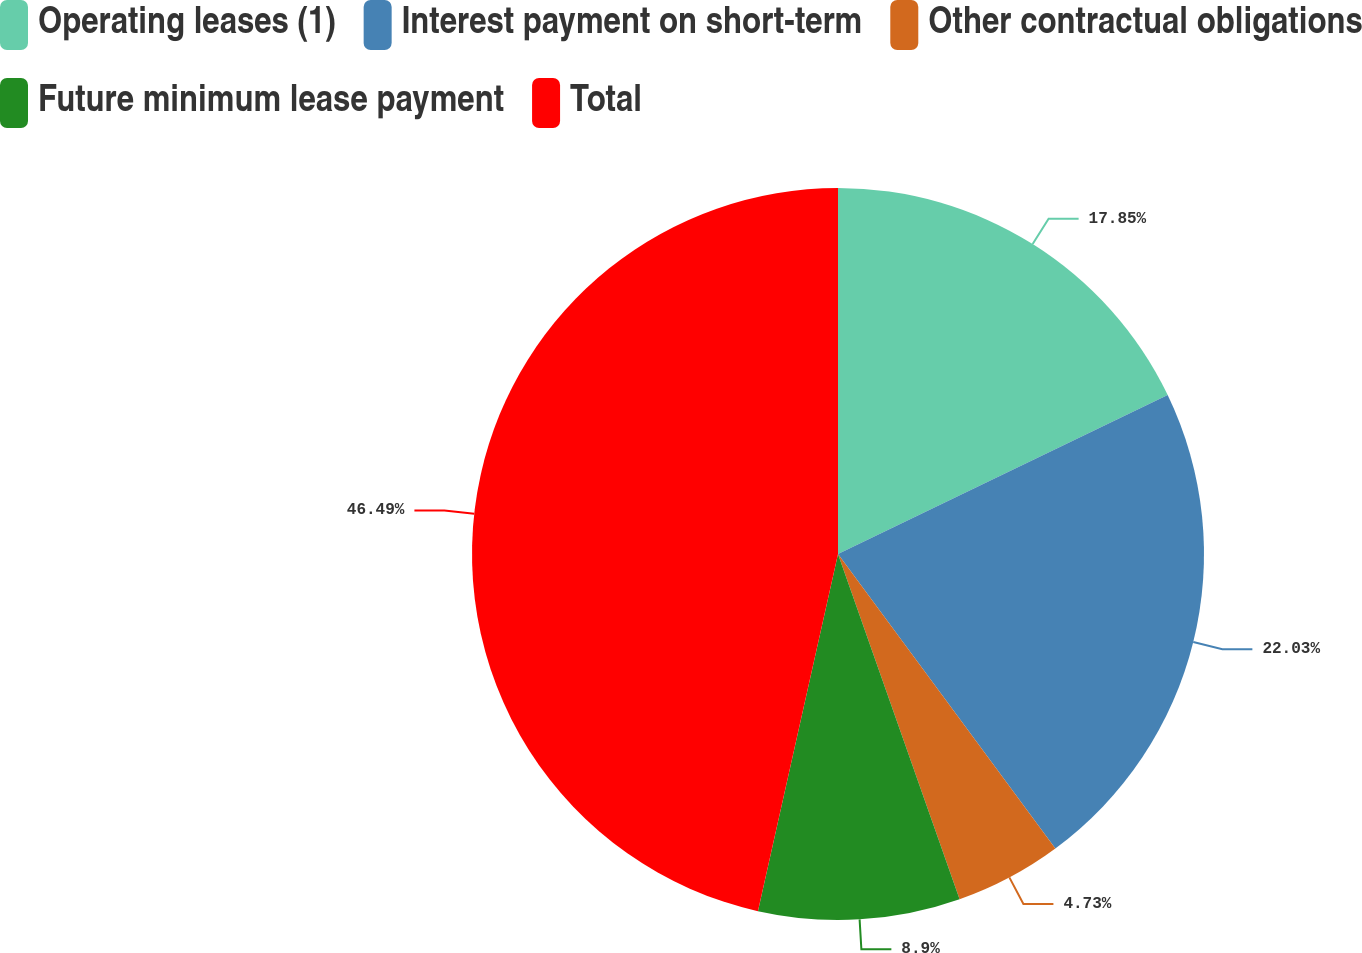Convert chart. <chart><loc_0><loc_0><loc_500><loc_500><pie_chart><fcel>Operating leases (1)<fcel>Interest payment on short-term<fcel>Other contractual obligations<fcel>Future minimum lease payment<fcel>Total<nl><fcel>17.85%<fcel>22.03%<fcel>4.73%<fcel>8.9%<fcel>46.49%<nl></chart> 